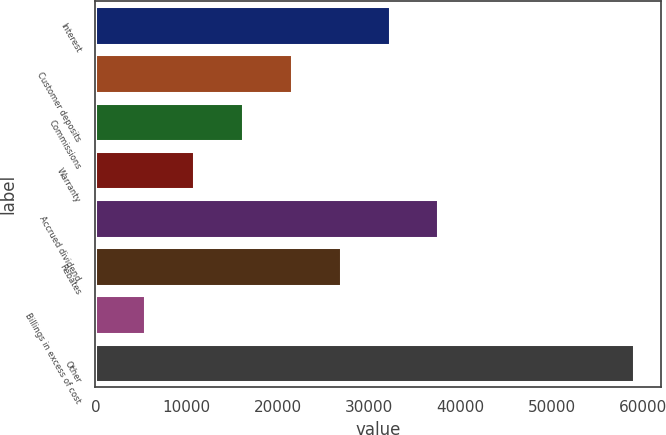Convert chart. <chart><loc_0><loc_0><loc_500><loc_500><bar_chart><fcel>Interest<fcel>Customer deposits<fcel>Commissions<fcel>Warranty<fcel>Accrued dividend<fcel>Rebates<fcel>Billings in excess of cost<fcel>Other<nl><fcel>32217<fcel>21515.8<fcel>16165.2<fcel>10814.6<fcel>37567.6<fcel>26866.4<fcel>5464<fcel>58970<nl></chart> 